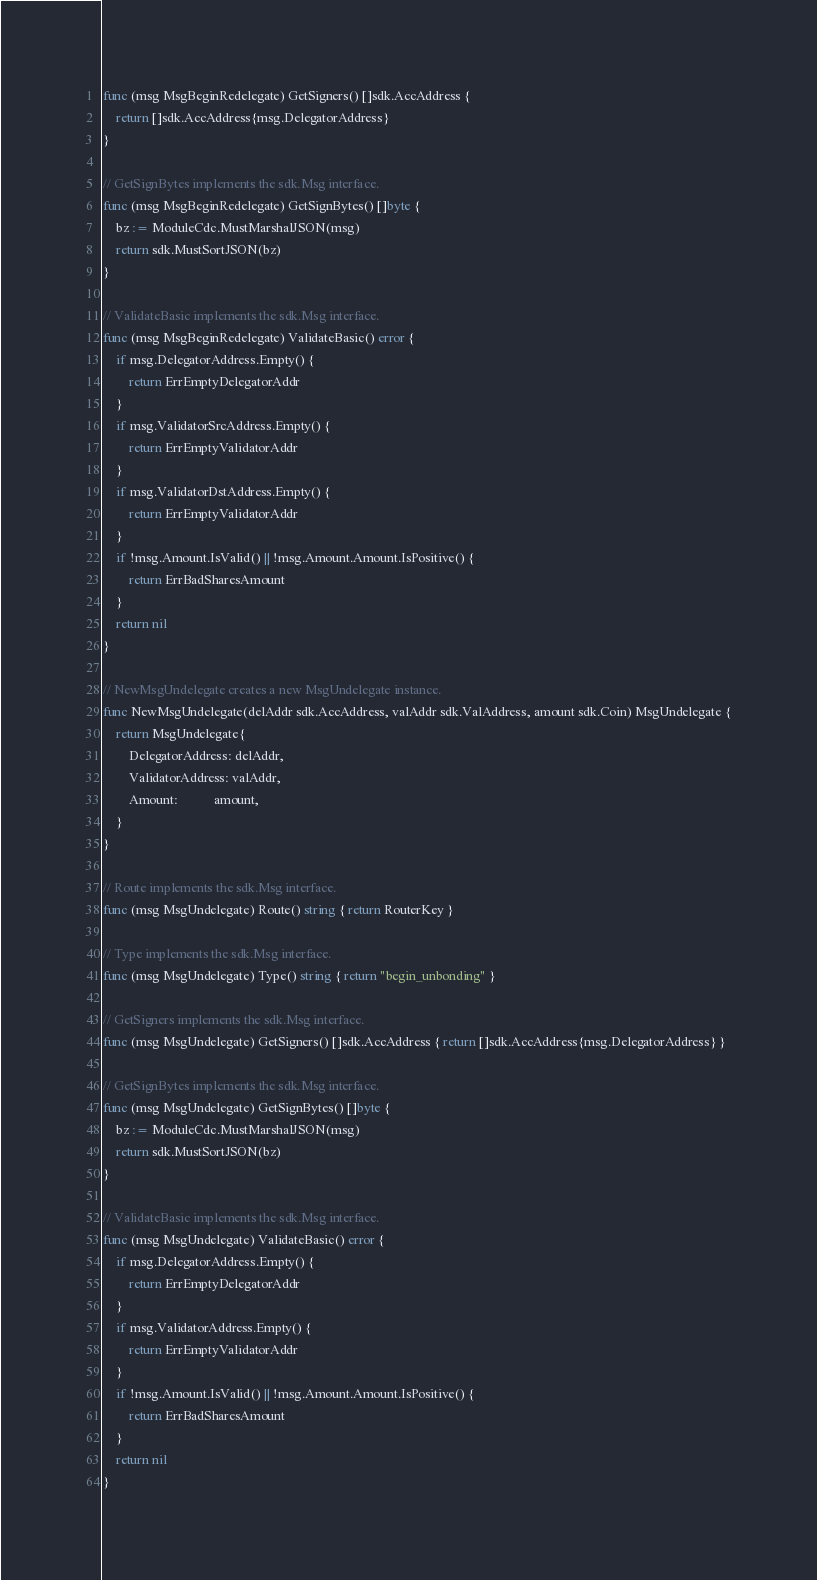Convert code to text. <code><loc_0><loc_0><loc_500><loc_500><_Go_>func (msg MsgBeginRedelegate) GetSigners() []sdk.AccAddress {
	return []sdk.AccAddress{msg.DelegatorAddress}
}

// GetSignBytes implements the sdk.Msg interface.
func (msg MsgBeginRedelegate) GetSignBytes() []byte {
	bz := ModuleCdc.MustMarshalJSON(msg)
	return sdk.MustSortJSON(bz)
}

// ValidateBasic implements the sdk.Msg interface.
func (msg MsgBeginRedelegate) ValidateBasic() error {
	if msg.DelegatorAddress.Empty() {
		return ErrEmptyDelegatorAddr
	}
	if msg.ValidatorSrcAddress.Empty() {
		return ErrEmptyValidatorAddr
	}
	if msg.ValidatorDstAddress.Empty() {
		return ErrEmptyValidatorAddr
	}
	if !msg.Amount.IsValid() || !msg.Amount.Amount.IsPositive() {
		return ErrBadSharesAmount
	}
	return nil
}

// NewMsgUndelegate creates a new MsgUndelegate instance.
func NewMsgUndelegate(delAddr sdk.AccAddress, valAddr sdk.ValAddress, amount sdk.Coin) MsgUndelegate {
	return MsgUndelegate{
		DelegatorAddress: delAddr,
		ValidatorAddress: valAddr,
		Amount:           amount,
	}
}

// Route implements the sdk.Msg interface.
func (msg MsgUndelegate) Route() string { return RouterKey }

// Type implements the sdk.Msg interface.
func (msg MsgUndelegate) Type() string { return "begin_unbonding" }

// GetSigners implements the sdk.Msg interface.
func (msg MsgUndelegate) GetSigners() []sdk.AccAddress { return []sdk.AccAddress{msg.DelegatorAddress} }

// GetSignBytes implements the sdk.Msg interface.
func (msg MsgUndelegate) GetSignBytes() []byte {
	bz := ModuleCdc.MustMarshalJSON(msg)
	return sdk.MustSortJSON(bz)
}

// ValidateBasic implements the sdk.Msg interface.
func (msg MsgUndelegate) ValidateBasic() error {
	if msg.DelegatorAddress.Empty() {
		return ErrEmptyDelegatorAddr
	}
	if msg.ValidatorAddress.Empty() {
		return ErrEmptyValidatorAddr
	}
	if !msg.Amount.IsValid() || !msg.Amount.Amount.IsPositive() {
		return ErrBadSharesAmount
	}
	return nil
}
</code> 